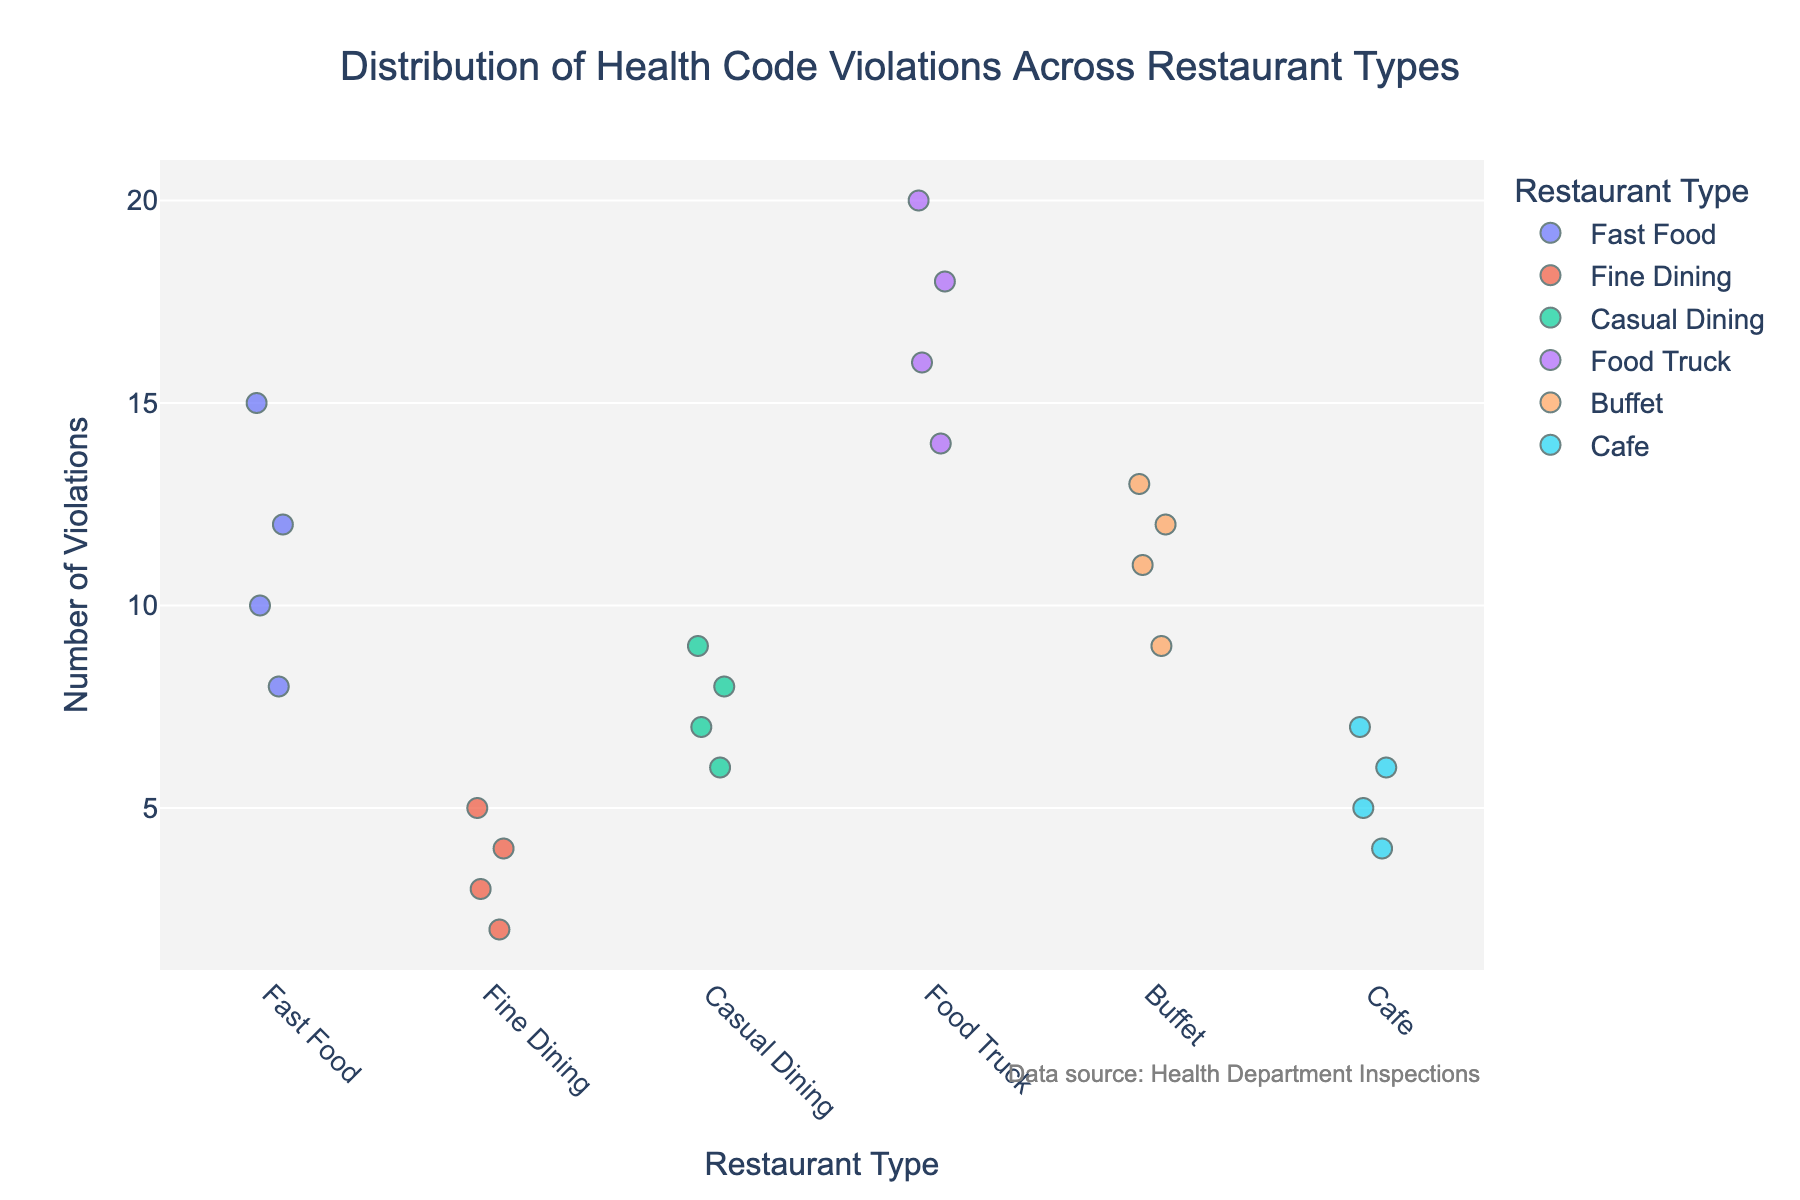How many different restaurant types are shown in the figure? By looking at the x-axis, we see distinct categories representing each restaurant type. Counting these categories gives us the number.
Answer: 5 Which restaurant type has the highest violation count? By observing the y-axis and identifying the highest data point, we can see that the "Food Truck" category has the highest count.
Answer: Food Truck What is the median number of violations for Fine Dining restaurants? Count the data points for Fine Dining, sort them, then the median is the middle value. For Fine Dining: [2, 3, 4, 5], the median is (3 +4)/2 = 3.5.
Answer: 3.5 Comparing Fast Food and Buffets, which has a higher range of violation counts? The range is calculated as the difference between the highest and lowest violation counts. For Fast Food: 15 - 8 = 7. For Buffets: 13 - 9 = 4.
Answer: Fast Food Which restaurant type shows the least variation in violation counts? Variation can be observed by the spread of data points for each restaurant type. The tightest cluster indicates the least variation. Fine Dining with violations ranging tightly between 2 and 5.
Answer: Fine Dining How many violations do Food Trucks have at minimum? Find the lowest data point in the Food Truck category on the y-axis. This minimum value is 14.
Answer: 14 What is the average number of violations for Cafes? Sum the violation counts for Cafes and divide by the number of data points. (5 + 7 + 4 + 6)/4 = 22/4 = 5.5.
Answer: 5.5 Are there any restaurant types that have overlapping violation count ranges? Overlapping occurs when the data points intersect in the y-axis. Both Fast Food (8-15) and Buffets (9-13) ranges overlap between 9 and 13 violations.
Answer: Yes Between Casual Dining and Fine Dining, which has a higher average number of violations? Calculate the averages. Casual Dining: (7 + 9 + 6 + 8)/4 = 30/4 = 7.5. Fine Dining: (3+5+2+4)/4 = 14/4 = 3.5.
Answer: Casual Dining Do any restaurant types have data points that fall exactly at 10 violations? Inspect each category for a data point at y=10. Only Fast Food and Buffet have exactly 10 and 10 respectively.
Answer: Yes 